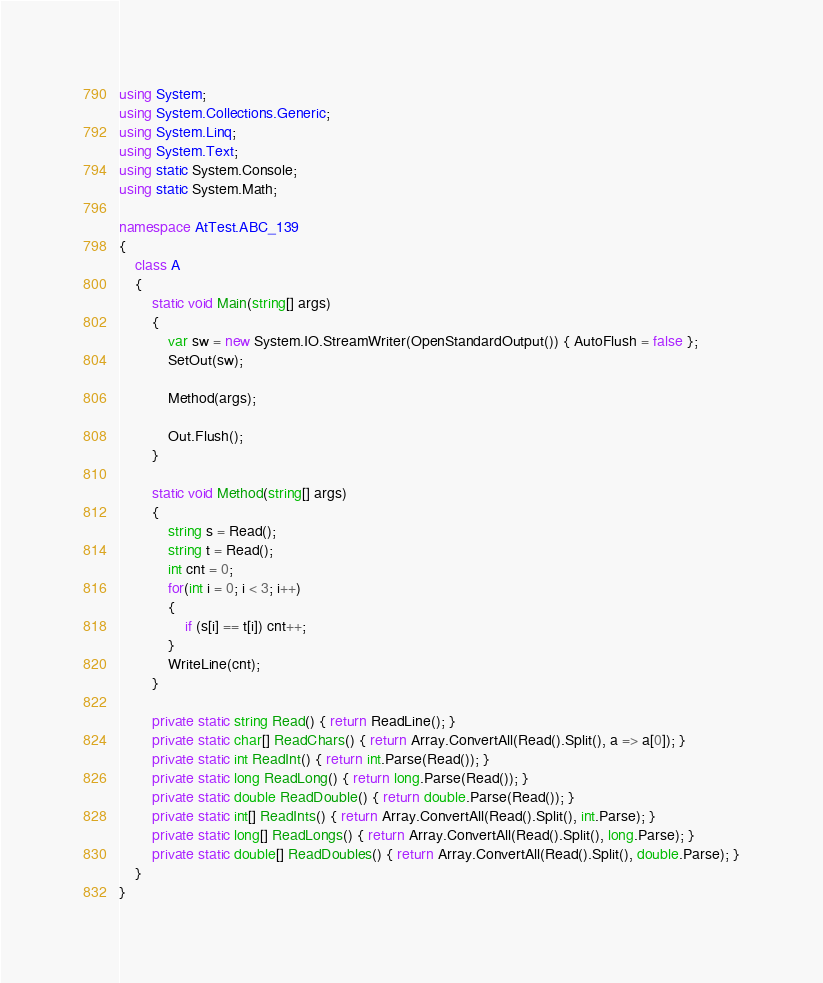<code> <loc_0><loc_0><loc_500><loc_500><_C#_>using System;
using System.Collections.Generic;
using System.Linq;
using System.Text;
using static System.Console;
using static System.Math;

namespace AtTest.ABC_139
{
    class A
    {
        static void Main(string[] args)
        {
            var sw = new System.IO.StreamWriter(OpenStandardOutput()) { AutoFlush = false };
            SetOut(sw);

            Method(args);

            Out.Flush();
        }

        static void Method(string[] args)
        {
            string s = Read();
            string t = Read();
            int cnt = 0;
            for(int i = 0; i < 3; i++)
            {
                if (s[i] == t[i]) cnt++;
            }
            WriteLine(cnt);
        }

        private static string Read() { return ReadLine(); }
        private static char[] ReadChars() { return Array.ConvertAll(Read().Split(), a => a[0]); }
        private static int ReadInt() { return int.Parse(Read()); }
        private static long ReadLong() { return long.Parse(Read()); }
        private static double ReadDouble() { return double.Parse(Read()); }
        private static int[] ReadInts() { return Array.ConvertAll(Read().Split(), int.Parse); }
        private static long[] ReadLongs() { return Array.ConvertAll(Read().Split(), long.Parse); }
        private static double[] ReadDoubles() { return Array.ConvertAll(Read().Split(), double.Parse); }
    }
}
</code> 